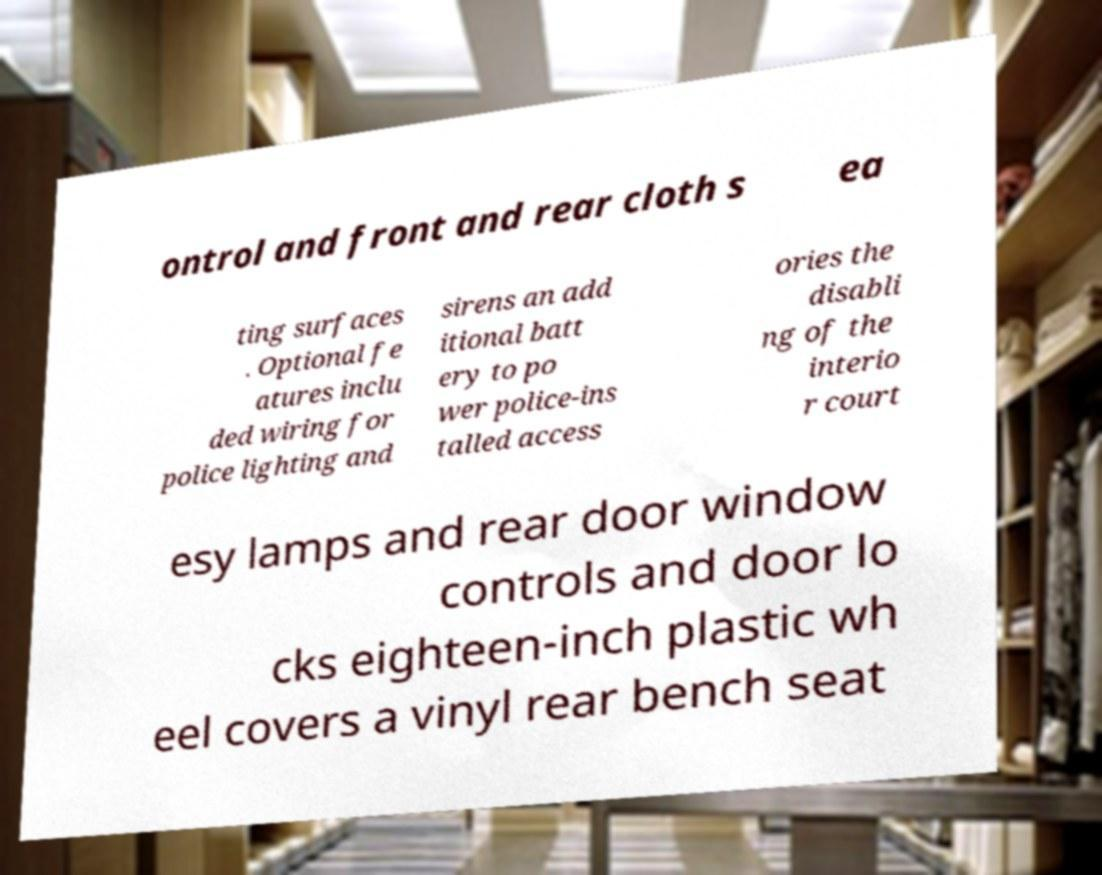There's text embedded in this image that I need extracted. Can you transcribe it verbatim? ontrol and front and rear cloth s ea ting surfaces . Optional fe atures inclu ded wiring for police lighting and sirens an add itional batt ery to po wer police-ins talled access ories the disabli ng of the interio r court esy lamps and rear door window controls and door lo cks eighteen-inch plastic wh eel covers a vinyl rear bench seat 